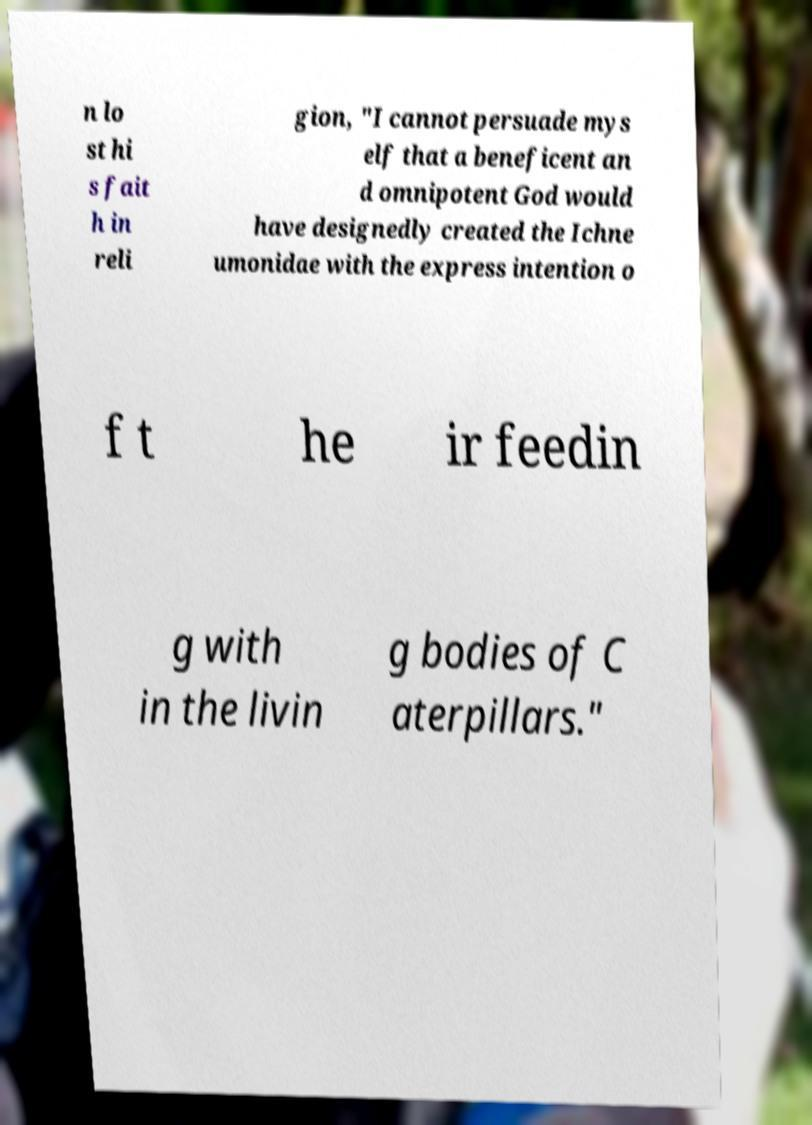Please identify and transcribe the text found in this image. n lo st hi s fait h in reli gion, "I cannot persuade mys elf that a beneficent an d omnipotent God would have designedly created the Ichne umonidae with the express intention o f t he ir feedin g with in the livin g bodies of C aterpillars." 